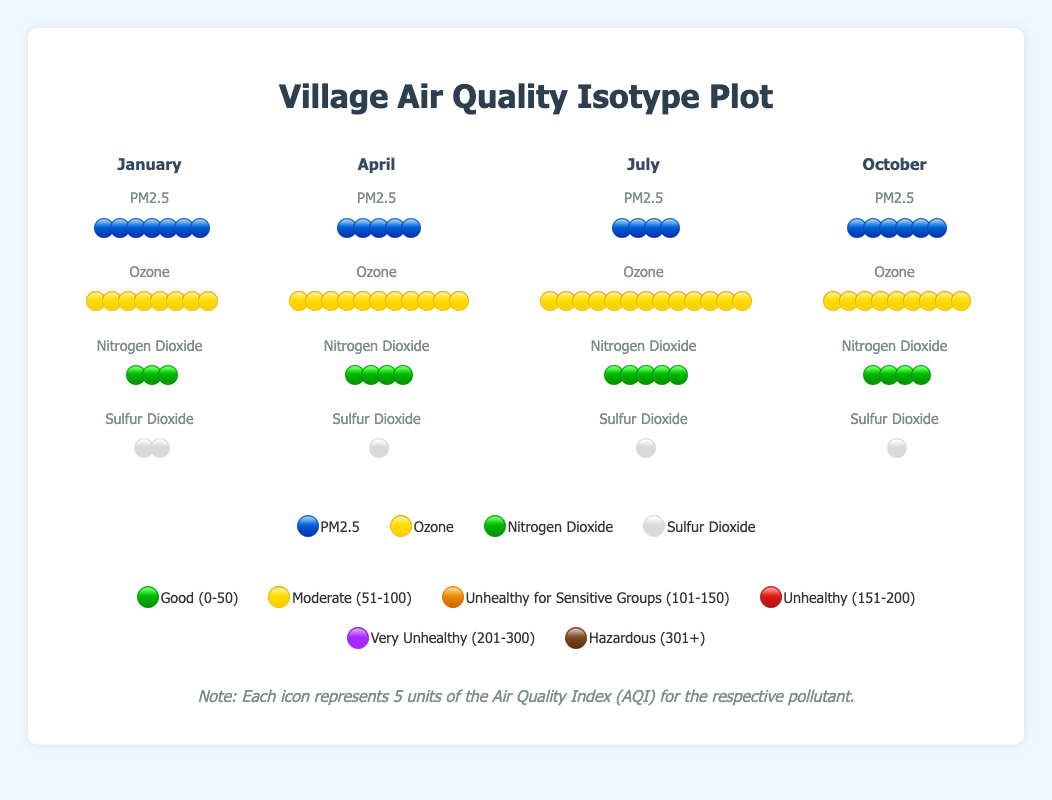What's the highest PM2.5 level across the months? By looking at the PM2.5 levels for each month, the January level with 35 units is the highest, represented by seven 🔵 icons.
Answer: 35 units In which month is the Ozone level the highest? By comparing the number of Ozone icons (🟡) between months, we see that July has the highest Ozone level with 13 icons.
Answer: July How many Nitrogen Dioxide units are recorded in April? Nitrogen Dioxide units for April are represented as four 🟢 icons, each representing 5 units, hence 4 * 5 = 20 units.
Answer: 20 units Compare the Sulfur Dioxide levels between January and October. Which month has higher levels? January has 2 ⚪ icons representing 10 units, and October has 1 ⚪ icon representing 5 units. Thus, January has higher Sulfur Dioxide levels.
Answer: January What's the average PM2.5 level across the four months? The PM2.5 levels are January: 35, April: 28, July: 22, and October: 30. Adding these (35 + 28 + 22 + 30) = 115, then dividing by 4 months, the average is 115/4 = 28.75 units.
Answer: 28.75 units Which pollutant level remains consistently low across all months? Sulfur Dioxide levels are consistently low, with levels being 8, 6, 5, and 7 units respectively for each month, all represented by very few ⚪ icons.
Answer: Sulfur Dioxide What's the total Ozone level across all months combined? Adding the Ozone levels: January: 42, April: 55, July: 68, and October: 48. The total becomes 42 + 55 + 68 + 48 = 213 units.
Answer: 213 units What is the difference in Nitrogen Dioxide levels between July and January? Nitrogen Dioxide levels: July has 25 units (5 🟢 icons), January has 18 units (3 🟢 icons). The difference is 25 - 18 = 7 units.
Answer: 7 units What's the average Sulfur Dioxide level over the four months? Adding the Sulfur Dioxide levels for January: 8, April: 6, July: 5, and October: 7, we get 8 + 6 + 5 + 7 = 26, then divided by 4, the average is 26/4 = 6.5 units.
Answer: 6.5 units 